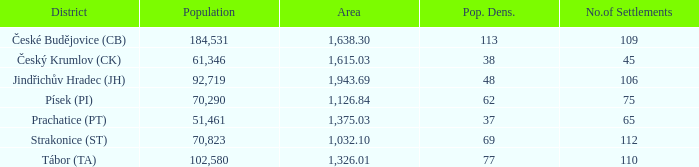How big is the area that has a population density of 113 and a population larger than 184,531? 0.0. 